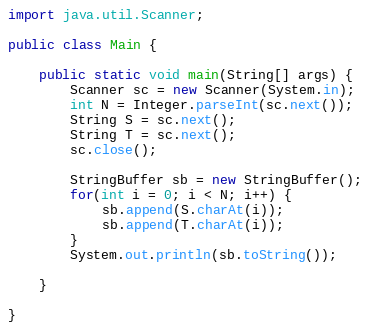<code> <loc_0><loc_0><loc_500><loc_500><_Java_>import java.util.Scanner;

public class Main {

	public static void main(String[] args) {
		Scanner sc = new Scanner(System.in);
		int N = Integer.parseInt(sc.next());
		String S = sc.next();
		String T = sc.next();
		sc.close();

		StringBuffer sb = new StringBuffer();
		for(int i = 0; i < N; i++) {
			sb.append(S.charAt(i));
			sb.append(T.charAt(i));
		}
		System.out.println(sb.toString());

	}

}</code> 